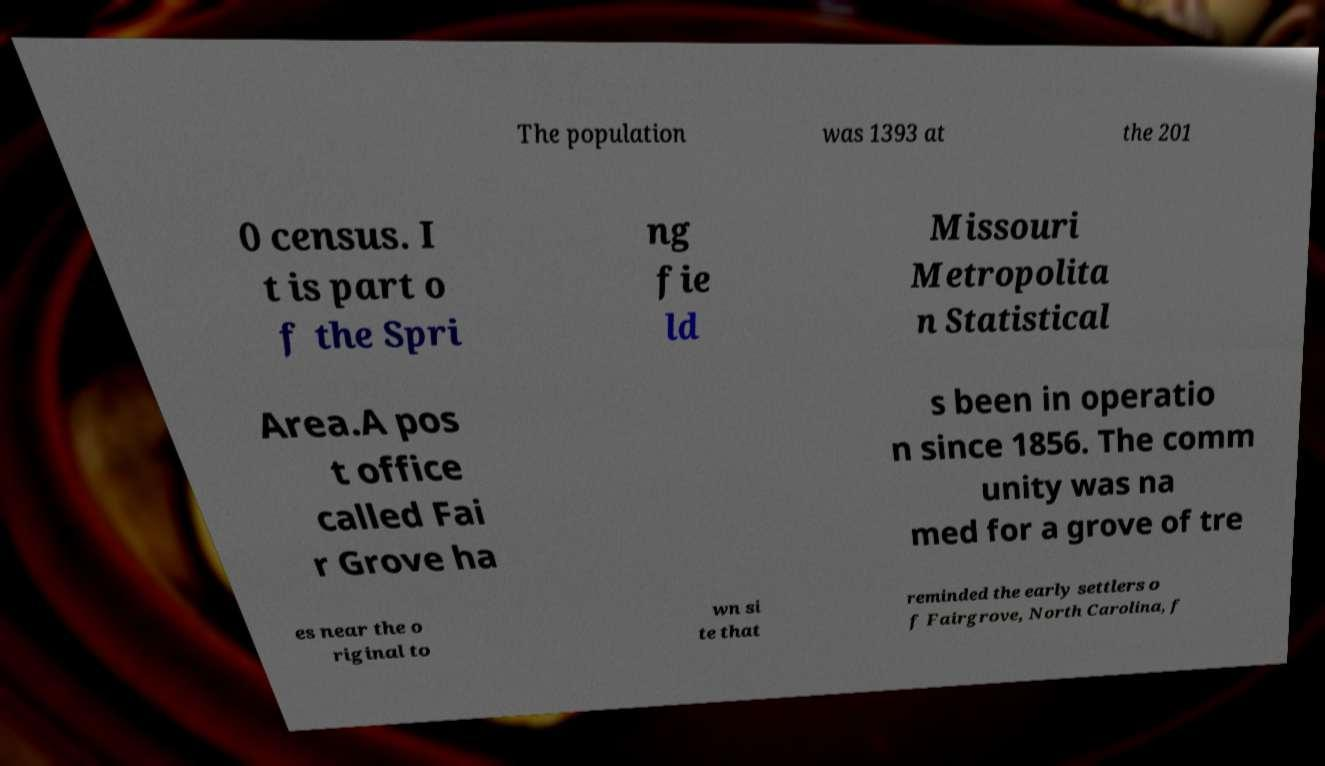Please identify and transcribe the text found in this image. The population was 1393 at the 201 0 census. I t is part o f the Spri ng fie ld Missouri Metropolita n Statistical Area.A pos t office called Fai r Grove ha s been in operatio n since 1856. The comm unity was na med for a grove of tre es near the o riginal to wn si te that reminded the early settlers o f Fairgrove, North Carolina, f 